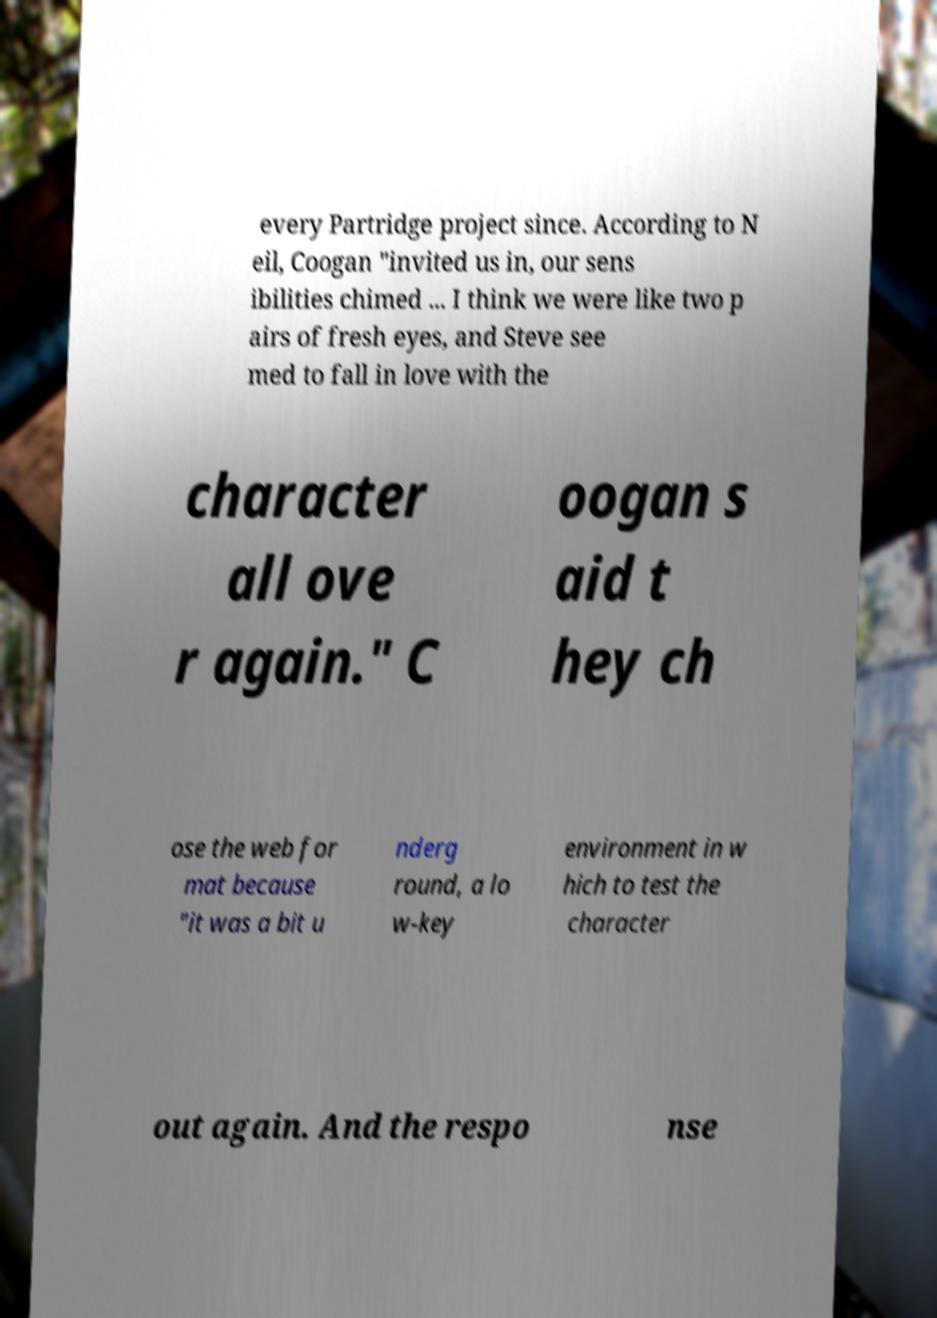Can you read and provide the text displayed in the image?This photo seems to have some interesting text. Can you extract and type it out for me? every Partridge project since. According to N eil, Coogan "invited us in, our sens ibilities chimed ... I think we were like two p airs of fresh eyes, and Steve see med to fall in love with the character all ove r again." C oogan s aid t hey ch ose the web for mat because "it was a bit u nderg round, a lo w-key environment in w hich to test the character out again. And the respo nse 